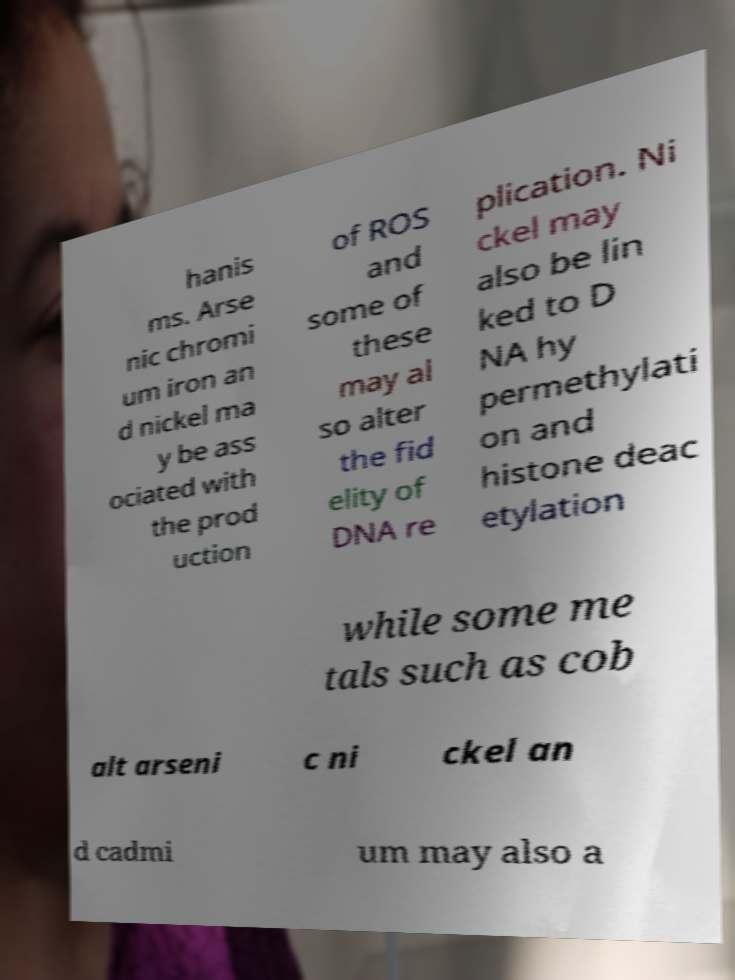Please read and relay the text visible in this image. What does it say? hanis ms. Arse nic chromi um iron an d nickel ma y be ass ociated with the prod uction of ROS and some of these may al so alter the fid elity of DNA re plication. Ni ckel may also be lin ked to D NA hy permethylati on and histone deac etylation while some me tals such as cob alt arseni c ni ckel an d cadmi um may also a 